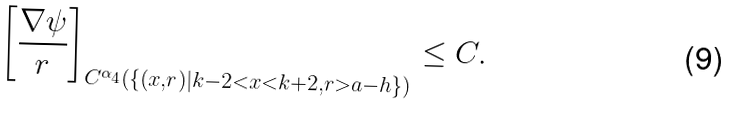<formula> <loc_0><loc_0><loc_500><loc_500>\left [ \frac { \nabla \psi } { r } \right ] _ { C ^ { \alpha _ { 4 } } ( \{ ( x , r ) | k - 2 < x < k + 2 , r > a - h \} ) } \leq C .</formula> 